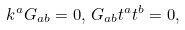Convert formula to latex. <formula><loc_0><loc_0><loc_500><loc_500>k ^ { a } G _ { a b } = 0 , \, G _ { a b } t ^ { a } t ^ { b } = 0 ,</formula> 